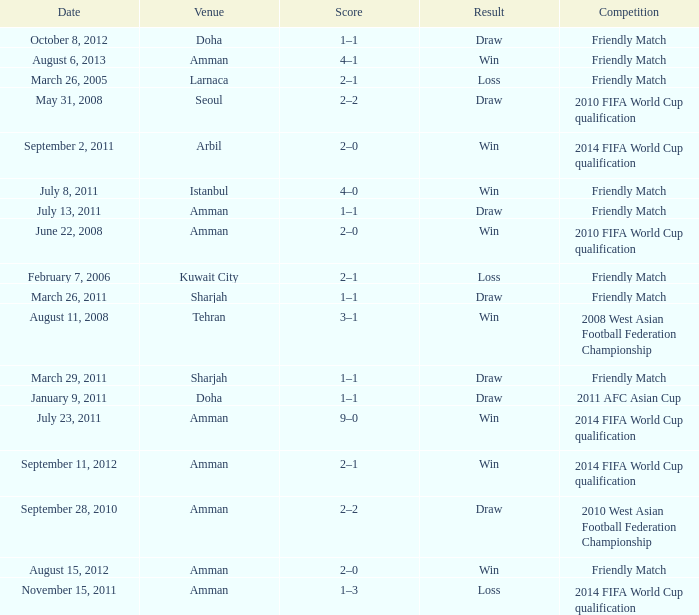During the loss on march 26, 2005, what was the venue where the match was played? Larnaca. 